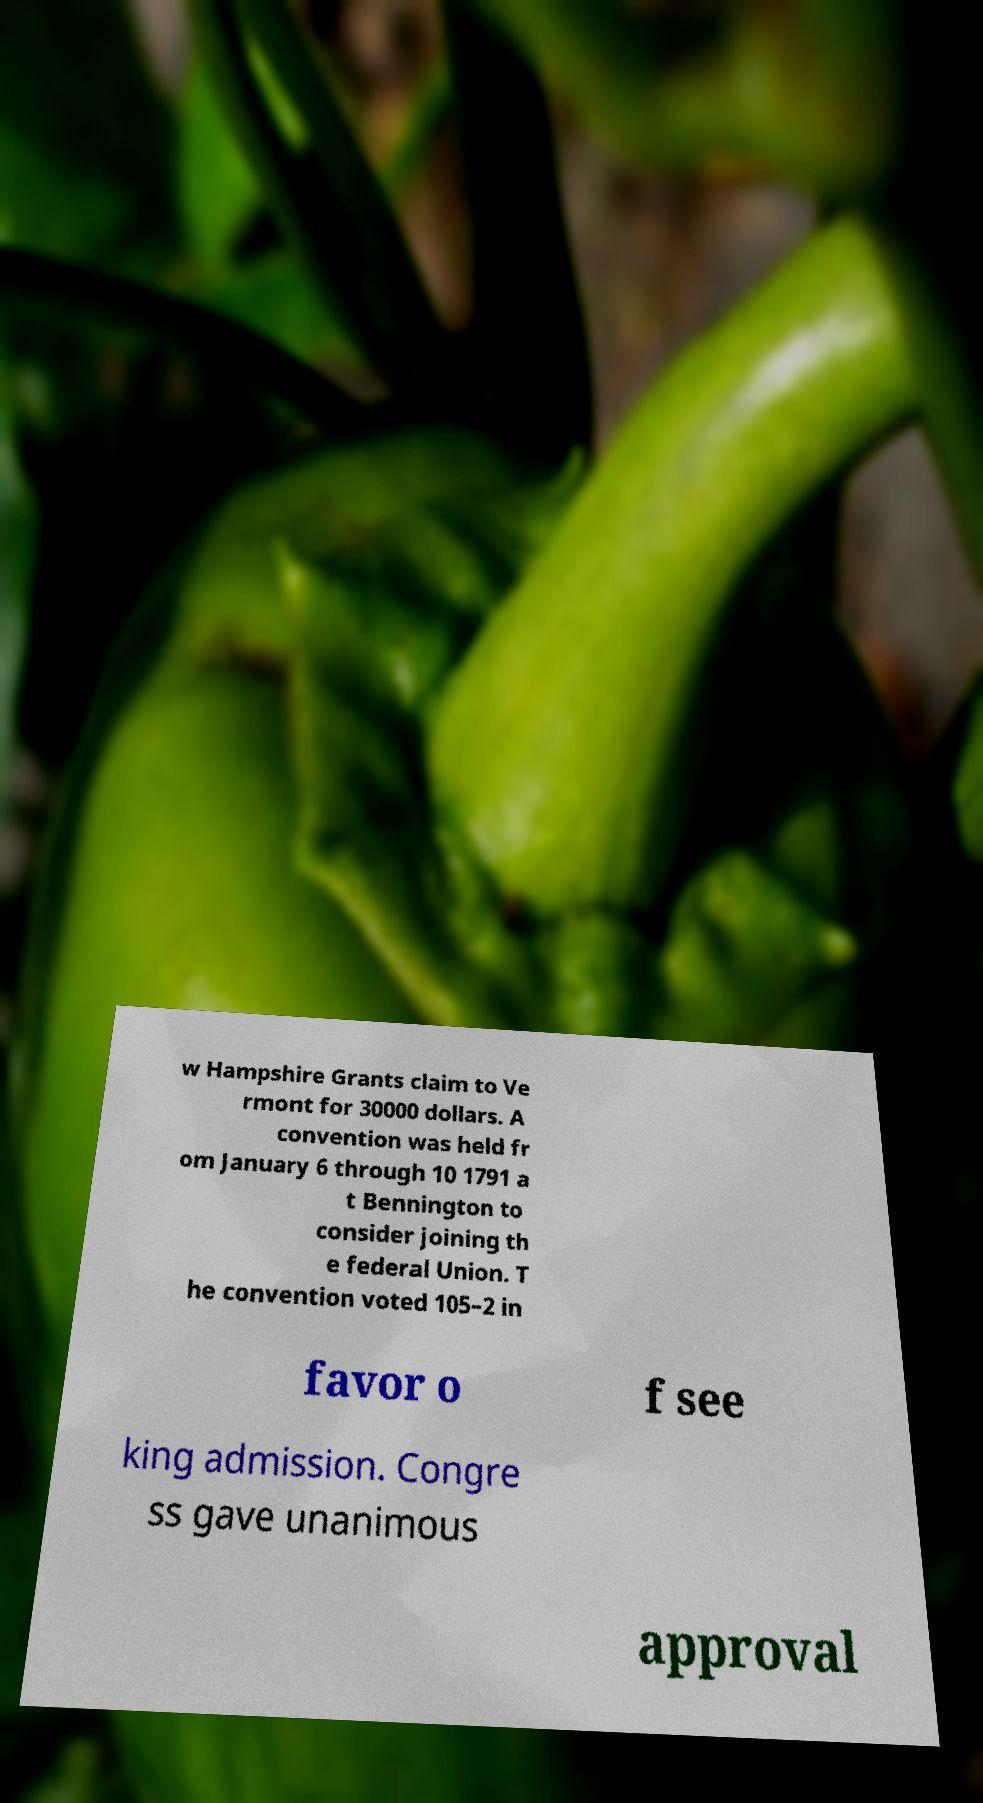Please identify and transcribe the text found in this image. w Hampshire Grants claim to Ve rmont for 30000 dollars. A convention was held fr om January 6 through 10 1791 a t Bennington to consider joining th e federal Union. T he convention voted 105–2 in favor o f see king admission. Congre ss gave unanimous approval 